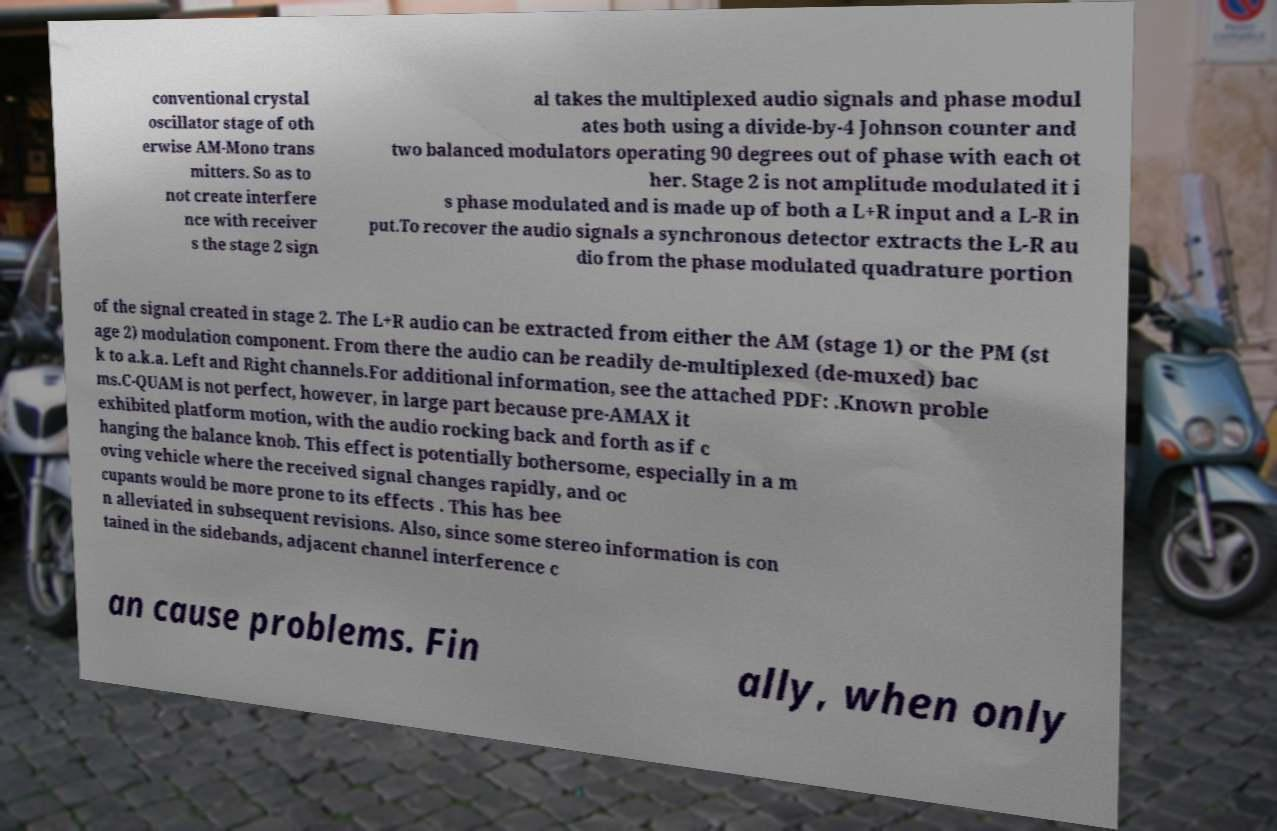Can you accurately transcribe the text from the provided image for me? conventional crystal oscillator stage of oth erwise AM-Mono trans mitters. So as to not create interfere nce with receiver s the stage 2 sign al takes the multiplexed audio signals and phase modul ates both using a divide-by-4 Johnson counter and two balanced modulators operating 90 degrees out of phase with each ot her. Stage 2 is not amplitude modulated it i s phase modulated and is made up of both a L+R input and a L-R in put.To recover the audio signals a synchronous detector extracts the L-R au dio from the phase modulated quadrature portion of the signal created in stage 2. The L+R audio can be extracted from either the AM (stage 1) or the PM (st age 2) modulation component. From there the audio can be readily de-multiplexed (de-muxed) bac k to a.k.a. Left and Right channels.For additional information, see the attached PDF: .Known proble ms.C-QUAM is not perfect, however, in large part because pre-AMAX it exhibited platform motion, with the audio rocking back and forth as if c hanging the balance knob. This effect is potentially bothersome, especially in a m oving vehicle where the received signal changes rapidly, and oc cupants would be more prone to its effects . This has bee n alleviated in subsequent revisions. Also, since some stereo information is con tained in the sidebands, adjacent channel interference c an cause problems. Fin ally, when only 